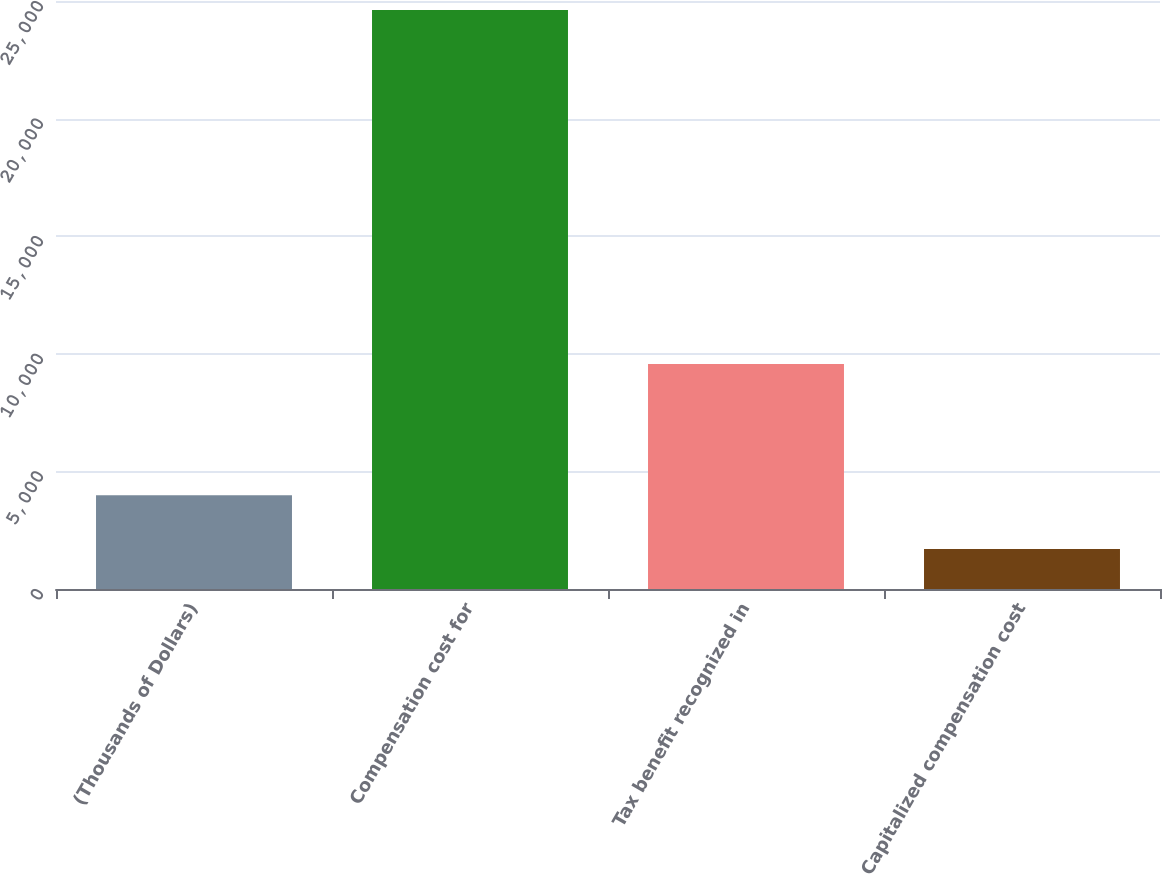Convert chart. <chart><loc_0><loc_0><loc_500><loc_500><bar_chart><fcel>(Thousands of Dollars)<fcel>Compensation cost for<fcel>Tax benefit recognized in<fcel>Capitalized compensation cost<nl><fcel>3989.5<fcel>24613<fcel>9571<fcel>1698<nl></chart> 